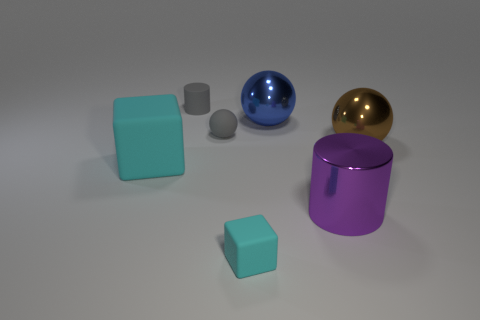Add 3 small cyan things. How many objects exist? 10 Subtract all cylinders. How many objects are left? 5 Subtract 1 gray spheres. How many objects are left? 6 Subtract all tiny rubber balls. Subtract all big blocks. How many objects are left? 5 Add 7 tiny cyan objects. How many tiny cyan objects are left? 8 Add 3 tiny gray matte things. How many tiny gray matte things exist? 5 